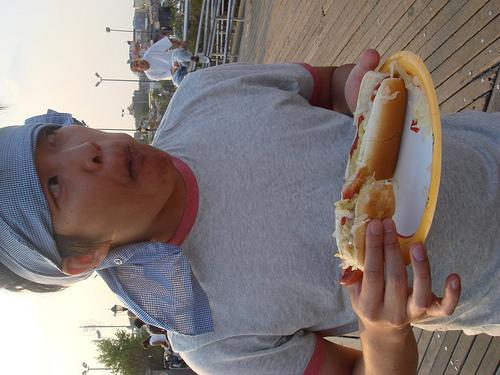Using a poetic style, describe the main subject and their surroundings. A youthful spirit, head wrapped in blue, feasts on hot dogs adorned with colors, amidst a wooden stage beneath clear skies. Using an informal tone, describe the person and their surroundings. A guy's rockin' a blue bandanna and grey shirt, munchin' on some hot dogs with all the fixings on a plate, chillin' on a wooden deck. Write a brief advertisement for the scene captured in the image. Relax and unwind on a light brown wooden deck, as you savor delicious hot dogs topped with ketchup, mustard, and onions, all served on a stylish white and yellow plate! Mention the clothing items and individual food components visible in the image. Blue bandanna, grey shirt, red collar; hot dogs with ketchup, mustard, onions, and light brown buns on a round, yellow plate. Explain what the person in the image is doing, focusing on their outfit. Wearing a blue bandanna and a grey shirt with a red collar, the person is having hot dogs with various toppings on a plate. Highlight the food items visible in the image and their placement. Two hot dogs with ketchup, mustard, and onions rest on a white and yellow plate, positioned on a light brown wooden surface. Mention the color palette in the image, focusing on the key objects. Blue bandanna, grey shirt, red collar, white and yellow plate, hot dogs with red ketchup and yellow mustard, light brown deck. Write a journalistic-style lead sentence that captures the essence of the image. Amidst casual surroundings, a young boy donning a blue bandanna and grey attire savors a plateful of hot dogs with a variety of condiments on a wooden deck. Mention the key elements of the scene in a single sentence. A boy with a blue bandanna and grey shirt enjoys hot dogs with ketchup, mustard, and onions on a white and yellow plate on a light brown wooden deck. List the main components of the image in a short phrase. Boy with blue bandanna, grey shirt, hot dogs on plate, wooden deck. 